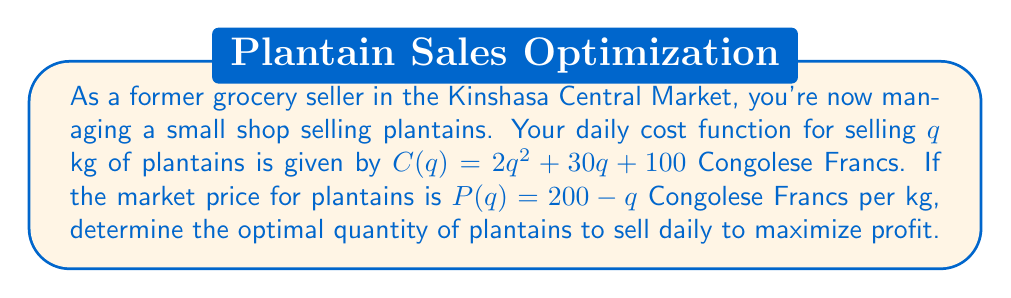Give your solution to this math problem. To find the optimal quantity, we need to use marginal cost analysis:

1) First, let's define the profit function:
   $\Pi(q) = R(q) - C(q)$, where $R(q)$ is revenue and $C(q)$ is cost.

2) Revenue function:
   $R(q) = P(q) \cdot q = (200 - q)q = 200q - q^2$

3) Profit function:
   $\Pi(q) = R(q) - C(q) = (200q - q^2) - (2q^2 + 30q + 100)$
   $\Pi(q) = 200q - q^2 - 2q^2 - 30q - 100$
   $\Pi(q) = 170q - 3q^2 - 100$

4) To maximize profit, find where marginal profit is zero:
   $\frac{d\Pi}{dq} = 170 - 6q = 0$

5) Solve for q:
   $170 - 6q = 0$
   $-6q = -170$
   $q = \frac{170}{6} \approx 28.33$

6) Verify it's a maximum by checking the second derivative:
   $\frac{d^2\Pi}{dq^2} = -6 < 0$, confirming a maximum.

Therefore, the optimal quantity to sell is approximately 28.33 kg of plantains daily.
Answer: 28.33 kg 